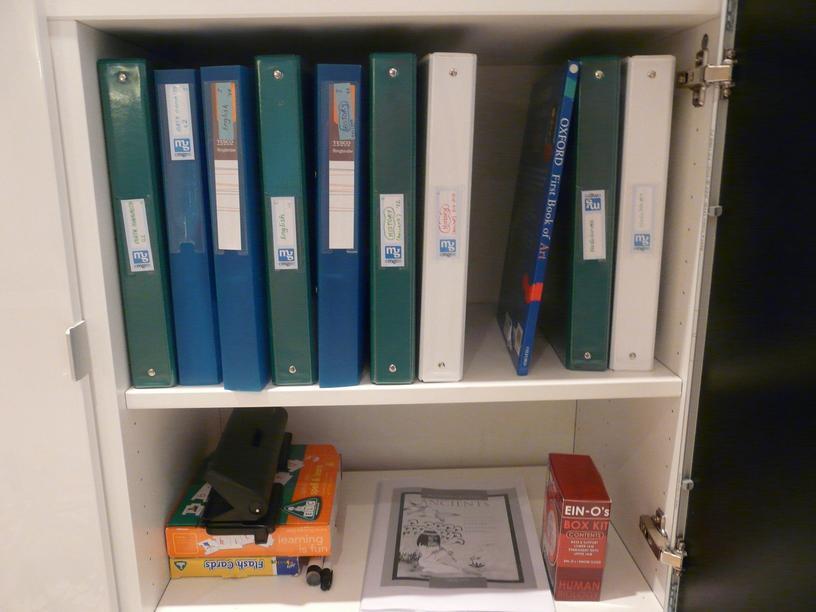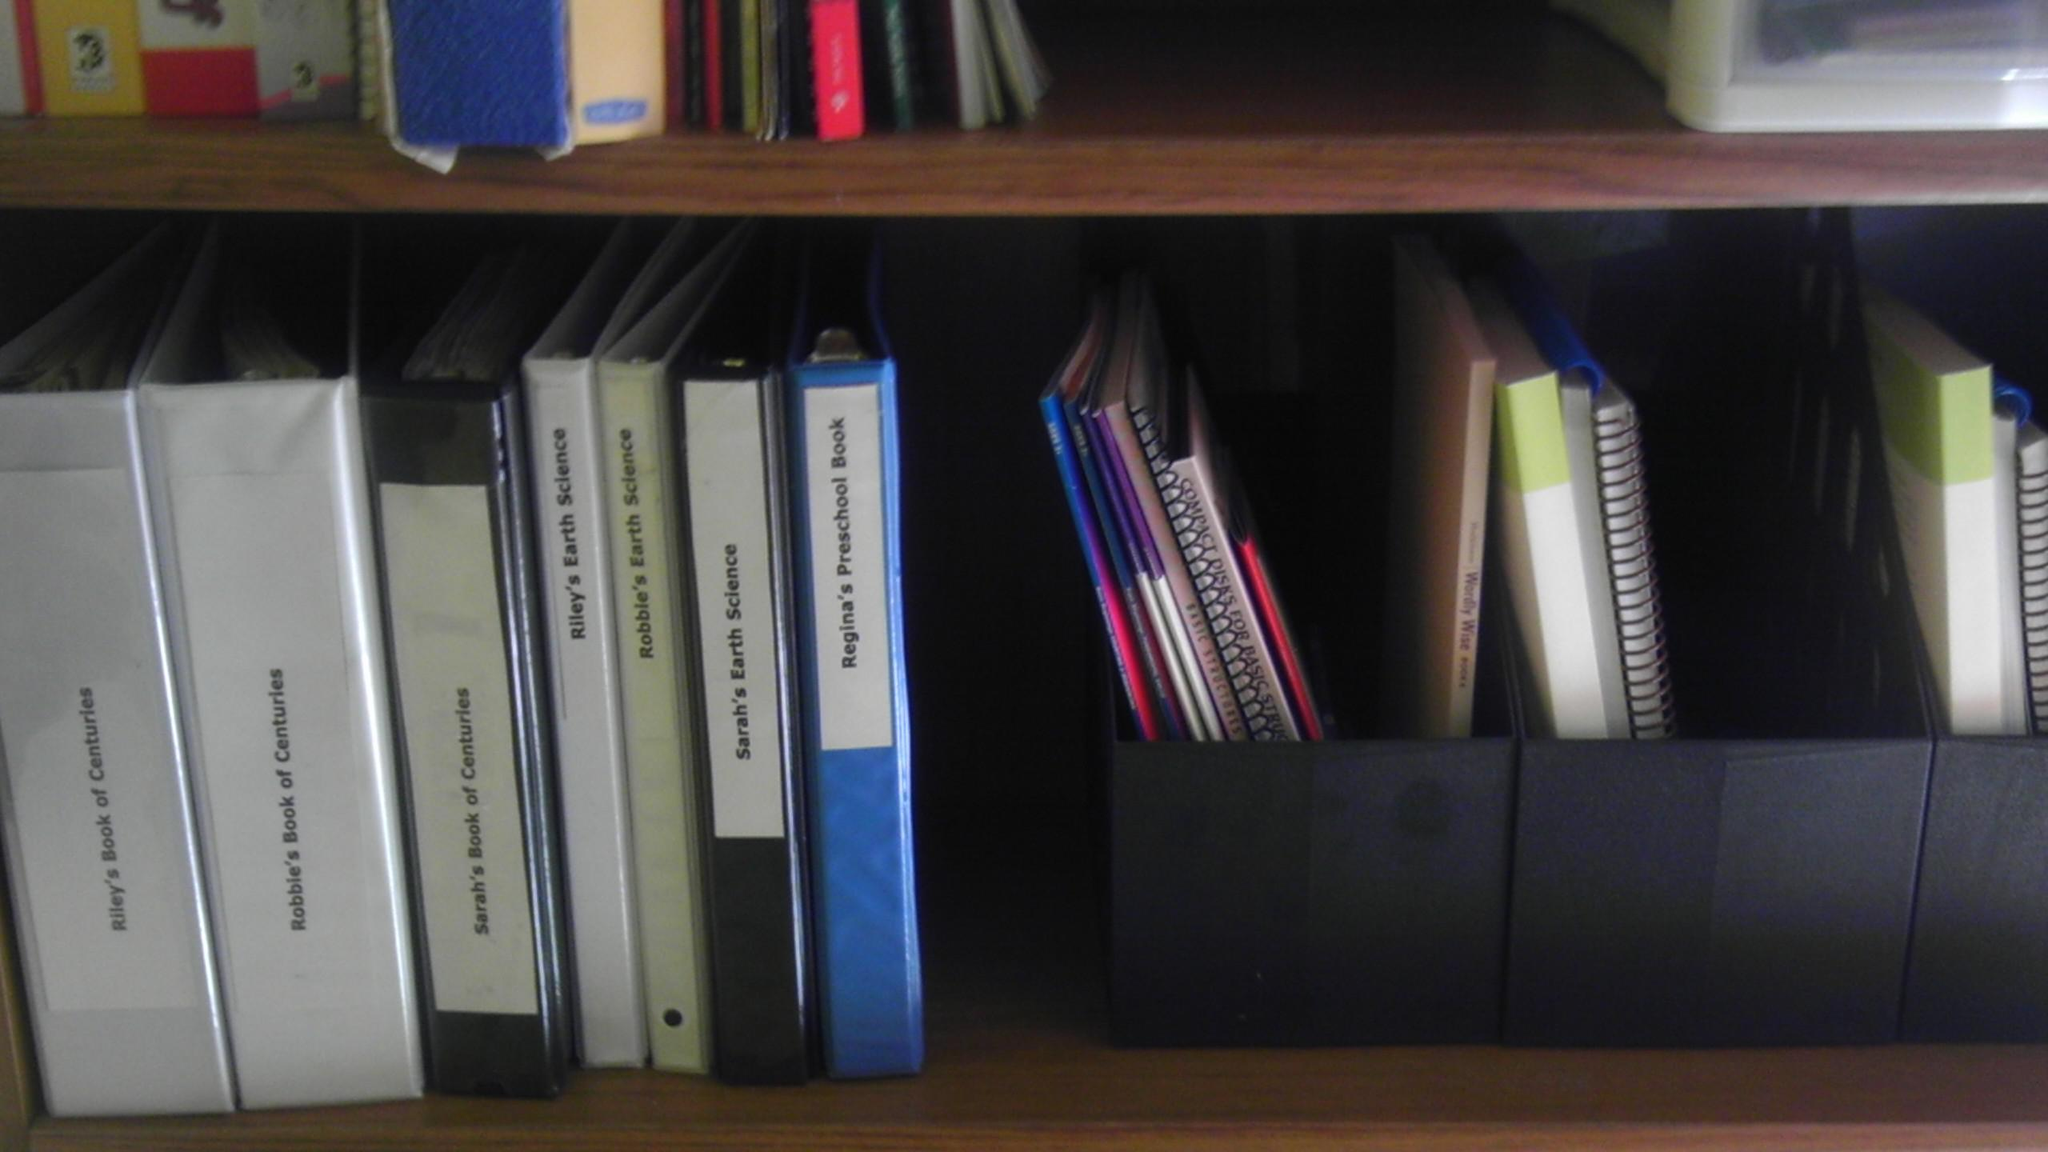The first image is the image on the left, the second image is the image on the right. Given the left and right images, does the statement "Exactly six binders of equal size are shown in one image." hold true? Answer yes or no. No. The first image is the image on the left, the second image is the image on the right. Assess this claim about the two images: "1 of the images has 6 shelf objects lined up in a row next to each other.". Correct or not? Answer yes or no. No. 